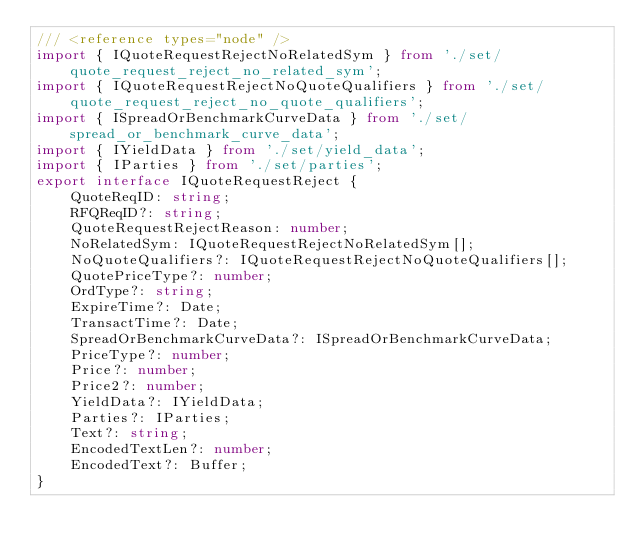Convert code to text. <code><loc_0><loc_0><loc_500><loc_500><_TypeScript_>/// <reference types="node" />
import { IQuoteRequestRejectNoRelatedSym } from './set/quote_request_reject_no_related_sym';
import { IQuoteRequestRejectNoQuoteQualifiers } from './set/quote_request_reject_no_quote_qualifiers';
import { ISpreadOrBenchmarkCurveData } from './set/spread_or_benchmark_curve_data';
import { IYieldData } from './set/yield_data';
import { IParties } from './set/parties';
export interface IQuoteRequestReject {
    QuoteReqID: string;
    RFQReqID?: string;
    QuoteRequestRejectReason: number;
    NoRelatedSym: IQuoteRequestRejectNoRelatedSym[];
    NoQuoteQualifiers?: IQuoteRequestRejectNoQuoteQualifiers[];
    QuotePriceType?: number;
    OrdType?: string;
    ExpireTime?: Date;
    TransactTime?: Date;
    SpreadOrBenchmarkCurveData?: ISpreadOrBenchmarkCurveData;
    PriceType?: number;
    Price?: number;
    Price2?: number;
    YieldData?: IYieldData;
    Parties?: IParties;
    Text?: string;
    EncodedTextLen?: number;
    EncodedText?: Buffer;
}
</code> 